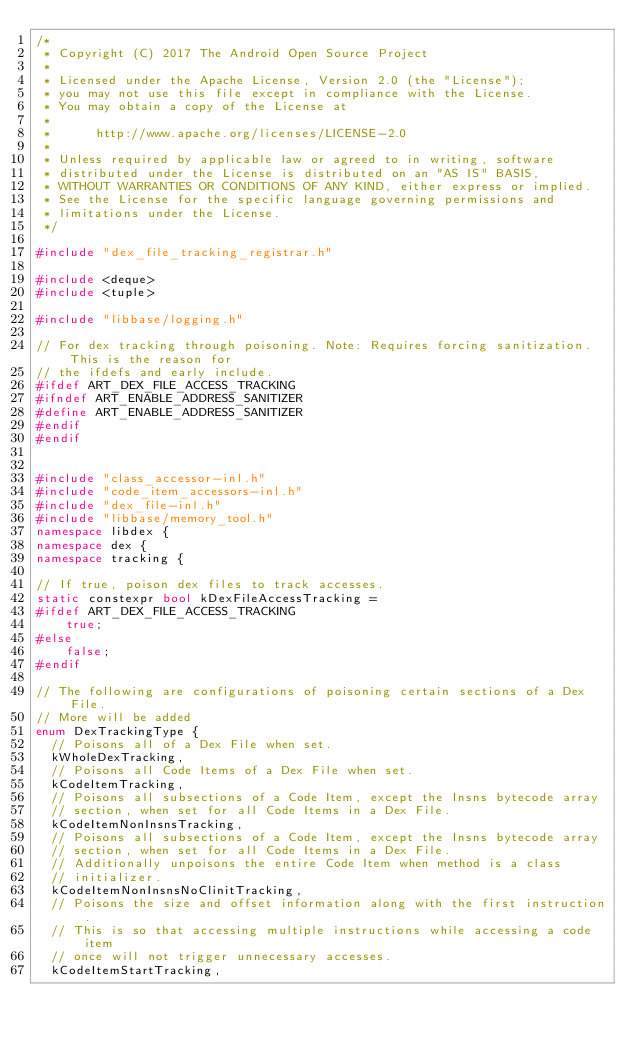Convert code to text. <code><loc_0><loc_0><loc_500><loc_500><_C++_>/*
 * Copyright (C) 2017 The Android Open Source Project
 *
 * Licensed under the Apache License, Version 2.0 (the "License");
 * you may not use this file except in compliance with the License.
 * You may obtain a copy of the License at
 *
 *      http://www.apache.org/licenses/LICENSE-2.0
 *
 * Unless required by applicable law or agreed to in writing, software
 * distributed under the License is distributed on an "AS IS" BASIS,
 * WITHOUT WARRANTIES OR CONDITIONS OF ANY KIND, either express or implied.
 * See the License for the specific language governing permissions and
 * limitations under the License.
 */

#include "dex_file_tracking_registrar.h"

#include <deque>
#include <tuple>

#include "libbase/logging.h"

// For dex tracking through poisoning. Note: Requires forcing sanitization. This is the reason for
// the ifdefs and early include.
#ifdef ART_DEX_FILE_ACCESS_TRACKING
#ifndef ART_ENABLE_ADDRESS_SANITIZER
#define ART_ENABLE_ADDRESS_SANITIZER
#endif
#endif


#include "class_accessor-inl.h"
#include "code_item_accessors-inl.h"
#include "dex_file-inl.h"
#include "libbase/memory_tool.h"
namespace libdex {
namespace dex {
namespace tracking {

// If true, poison dex files to track accesses.
static constexpr bool kDexFileAccessTracking =
#ifdef ART_DEX_FILE_ACCESS_TRACKING
    true;
#else
    false;
#endif

// The following are configurations of poisoning certain sections of a Dex File.
// More will be added
enum DexTrackingType {
  // Poisons all of a Dex File when set.
  kWholeDexTracking,
  // Poisons all Code Items of a Dex File when set.
  kCodeItemTracking,
  // Poisons all subsections of a Code Item, except the Insns bytecode array
  // section, when set for all Code Items in a Dex File.
  kCodeItemNonInsnsTracking,
  // Poisons all subsections of a Code Item, except the Insns bytecode array
  // section, when set for all Code Items in a Dex File.
  // Additionally unpoisons the entire Code Item when method is a class
  // initializer.
  kCodeItemNonInsnsNoClinitTracking,
  // Poisons the size and offset information along with the first instruction.
  // This is so that accessing multiple instructions while accessing a code item
  // once will not trigger unnecessary accesses.
  kCodeItemStartTracking,</code> 